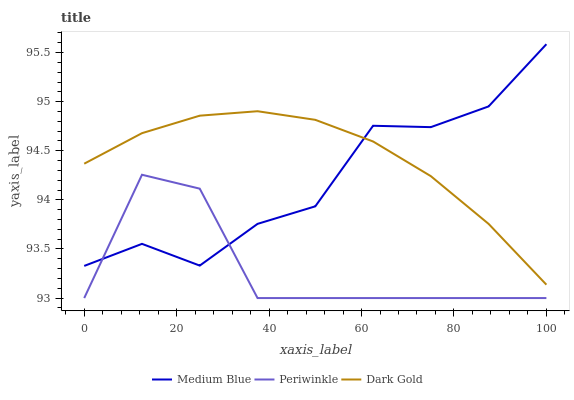Does Periwinkle have the minimum area under the curve?
Answer yes or no. Yes. Does Dark Gold have the maximum area under the curve?
Answer yes or no. Yes. Does Medium Blue have the minimum area under the curve?
Answer yes or no. No. Does Medium Blue have the maximum area under the curve?
Answer yes or no. No. Is Dark Gold the smoothest?
Answer yes or no. Yes. Is Periwinkle the roughest?
Answer yes or no. Yes. Is Medium Blue the smoothest?
Answer yes or no. No. Is Medium Blue the roughest?
Answer yes or no. No. Does Periwinkle have the lowest value?
Answer yes or no. Yes. Does Dark Gold have the lowest value?
Answer yes or no. No. Does Medium Blue have the highest value?
Answer yes or no. Yes. Does Dark Gold have the highest value?
Answer yes or no. No. Is Periwinkle less than Dark Gold?
Answer yes or no. Yes. Is Dark Gold greater than Periwinkle?
Answer yes or no. Yes. Does Dark Gold intersect Medium Blue?
Answer yes or no. Yes. Is Dark Gold less than Medium Blue?
Answer yes or no. No. Is Dark Gold greater than Medium Blue?
Answer yes or no. No. Does Periwinkle intersect Dark Gold?
Answer yes or no. No. 